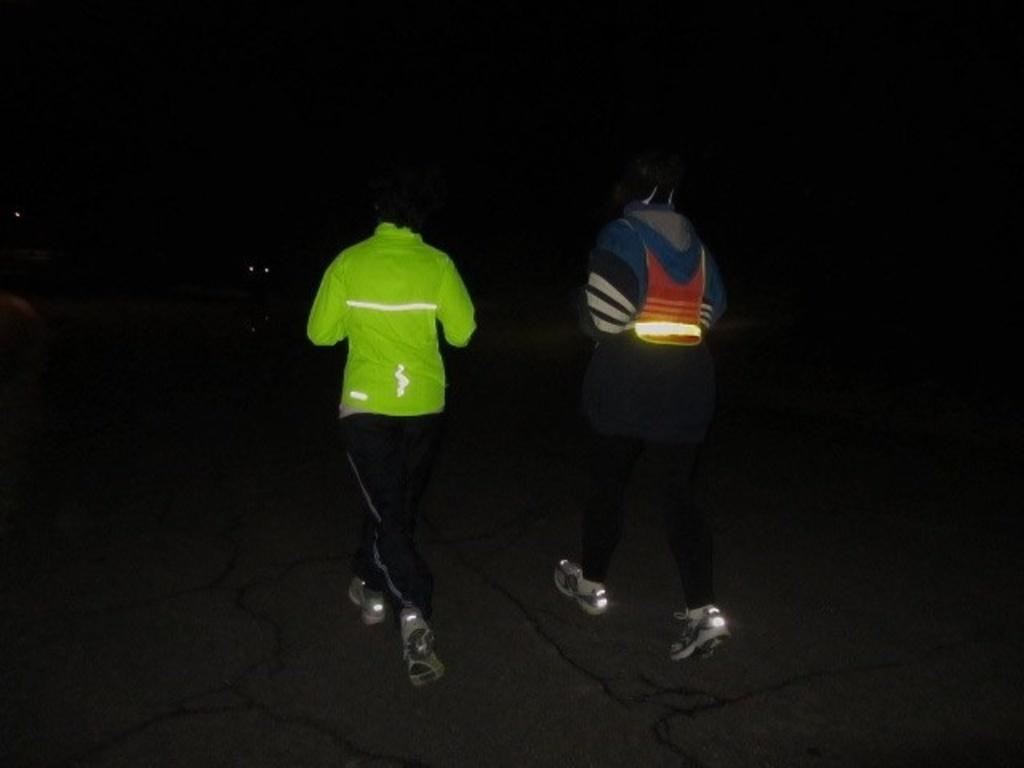How many people are in the image? There are two persons in the image. What can be observed about their clothing? The persons are wearing different color dresses. What type of footwear are the persons wearing? The persons are wearing shoes. What activity are the persons engaged in? The persons are running on the road. What is the color of the background in the image? The background of the image is dark in color. Can you see any jellyfish in the image? No, there are no jellyfish present in the image. What is the desire of the person wearing the red dress in the image? The image does not provide any information about the desires or intentions of the persons, so it cannot be determined. 